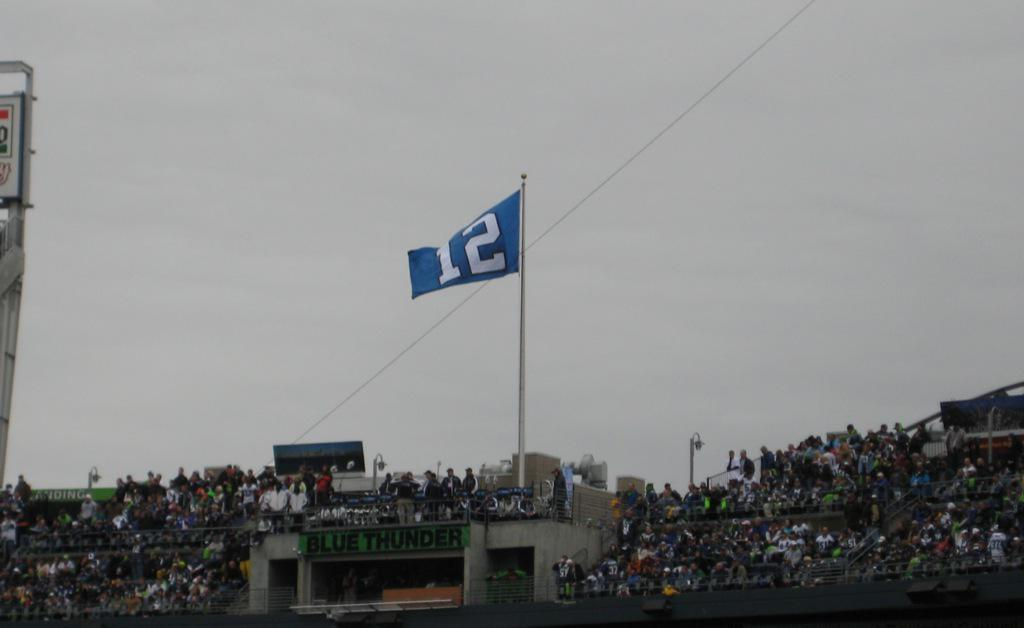<image>
Create a compact narrative representing the image presented. many people are gathered to see the blue thunder 